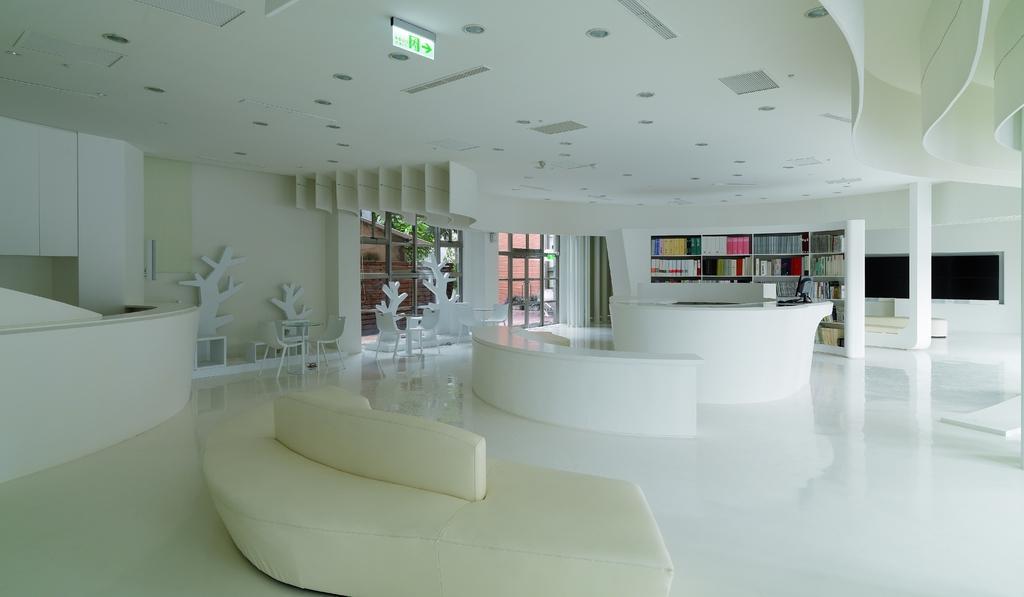Could you give a brief overview of what you see in this image? In the foreground of this image, there is a couch. On the left, there is a circular desk. On the top, there is a ceiling. In the middle, there are two circular desks. In the background, there are many books in the shelf, few chairs, glass door and the glass wall. Through the glass, there is a house, tree and the wall of a building. 